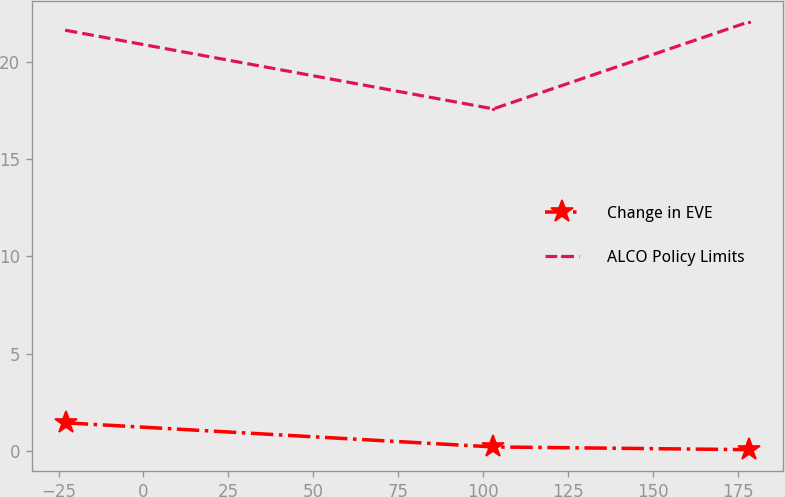Convert chart. <chart><loc_0><loc_0><loc_500><loc_500><line_chart><ecel><fcel>Change in EVE<fcel>ALCO Policy Limits<nl><fcel>-22.88<fcel>1.44<fcel>21.62<nl><fcel>103.05<fcel>0.2<fcel>17.58<nl><fcel>178.28<fcel>0.06<fcel>22.05<nl></chart> 